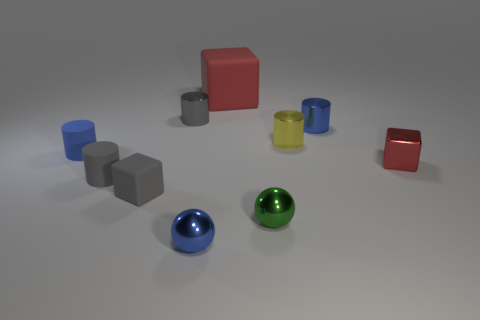Subtract all metallic blocks. How many blocks are left? 2 Subtract 2 cubes. How many cubes are left? 1 Subtract all cubes. How many objects are left? 7 Subtract all gray cubes. How many cubes are left? 2 Subtract all brown cylinders. How many red blocks are left? 2 Subtract all tiny metal cylinders. Subtract all large matte cubes. How many objects are left? 6 Add 7 tiny gray cubes. How many tiny gray cubes are left? 8 Add 9 big purple cubes. How many big purple cubes exist? 9 Subtract 1 yellow cylinders. How many objects are left? 9 Subtract all yellow cylinders. Subtract all green blocks. How many cylinders are left? 4 